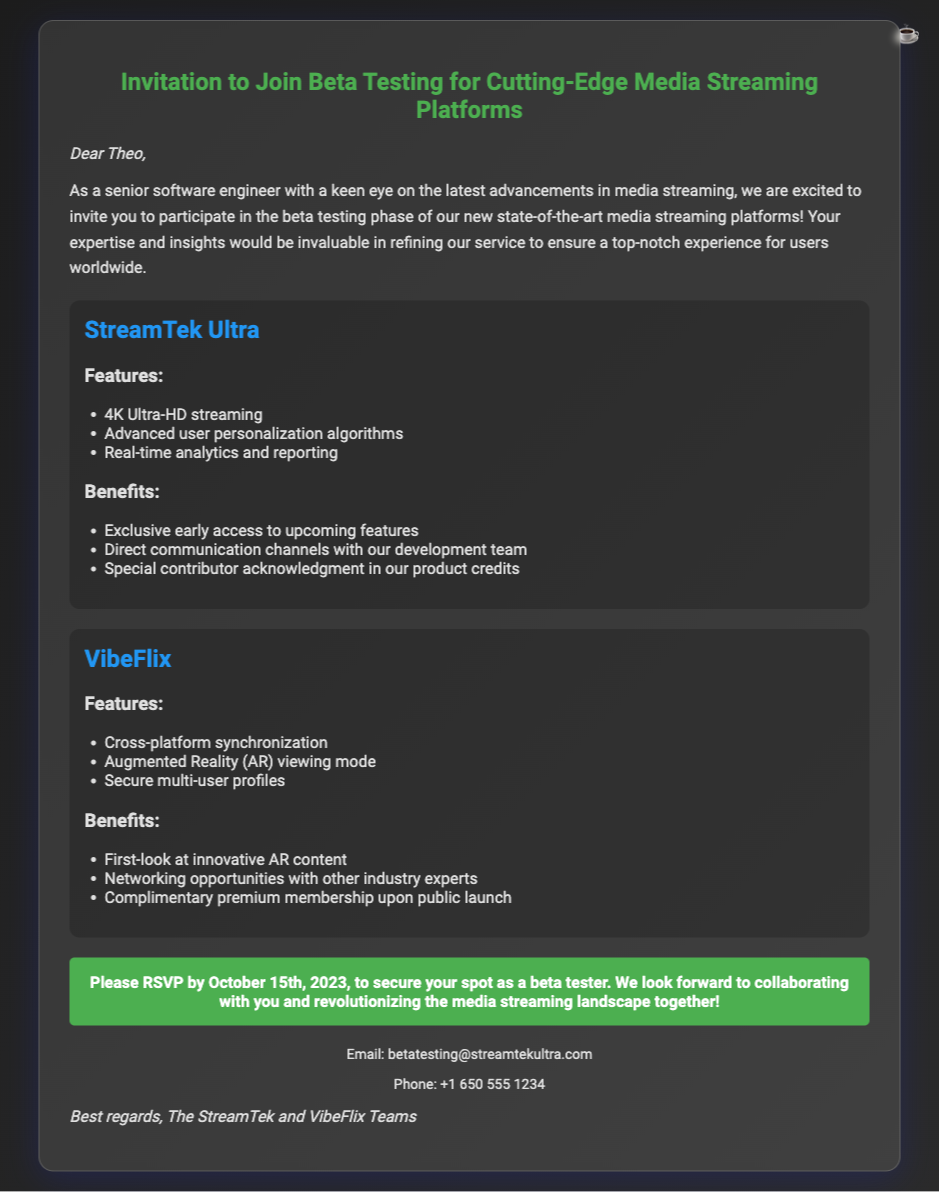What is the name of the first platform mentioned? The first platform mentioned is named StreamTek Ultra.
Answer: StreamTek Ultra What is the RSVP deadline date? The document specifies that RSVPs must be made by October 15th, 2023.
Answer: October 15th, 2023 What feature involves Augmented Reality? The feature listed in VibeFlix that involves Augmented Reality is the Augmented Reality (AR) viewing mode.
Answer: Augmented Reality (AR) viewing mode What benefit is offered for being a beta tester? One of the benefits offered is exclusive early access to upcoming features.
Answer: Exclusive early access to upcoming features How many platforms are mentioned in the document? There are two platforms mentioned in the document: StreamTek Ultra and VibeFlix.
Answer: Two 